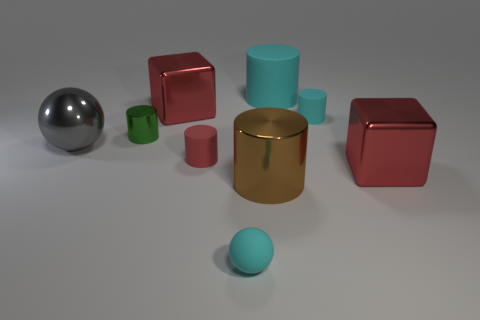Subtract all blue cylinders. Subtract all red spheres. How many cylinders are left? 5 Subtract all spheres. How many objects are left? 7 Add 7 large cylinders. How many large cylinders are left? 9 Add 9 large cyan things. How many large cyan things exist? 10 Subtract 0 cyan cubes. How many objects are left? 9 Subtract all tiny cyan balls. Subtract all small matte things. How many objects are left? 5 